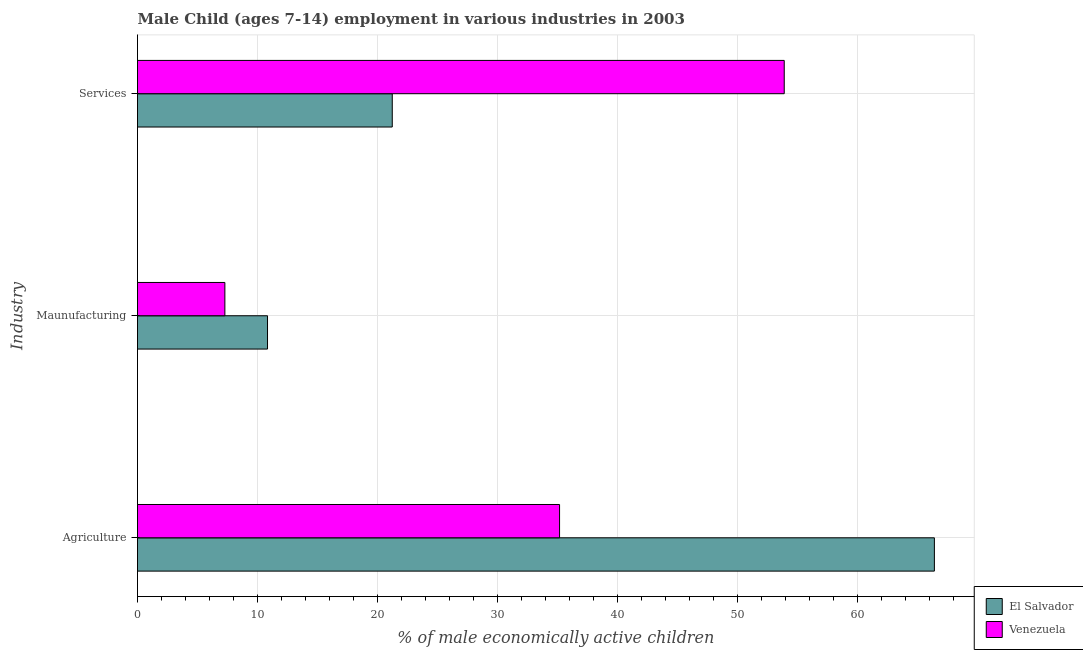How many groups of bars are there?
Offer a very short reply. 3. Are the number of bars on each tick of the Y-axis equal?
Offer a terse response. Yes. How many bars are there on the 2nd tick from the bottom?
Your answer should be compact. 2. What is the label of the 3rd group of bars from the top?
Provide a succinct answer. Agriculture. What is the percentage of economically active children in services in El Salvador?
Offer a very short reply. 21.22. Across all countries, what is the maximum percentage of economically active children in services?
Keep it short and to the point. 53.87. Across all countries, what is the minimum percentage of economically active children in manufacturing?
Keep it short and to the point. 7.28. In which country was the percentage of economically active children in agriculture maximum?
Make the answer very short. El Salvador. In which country was the percentage of economically active children in agriculture minimum?
Keep it short and to the point. Venezuela. What is the total percentage of economically active children in agriculture in the graph?
Your response must be concise. 101.54. What is the difference between the percentage of economically active children in agriculture in El Salvador and that in Venezuela?
Keep it short and to the point. 31.23. What is the difference between the percentage of economically active children in services in El Salvador and the percentage of economically active children in agriculture in Venezuela?
Provide a short and direct response. -13.94. What is the average percentage of economically active children in manufacturing per country?
Your answer should be very brief. 9.05. What is the difference between the percentage of economically active children in services and percentage of economically active children in manufacturing in Venezuela?
Your answer should be compact. 46.6. What is the ratio of the percentage of economically active children in agriculture in Venezuela to that in El Salvador?
Make the answer very short. 0.53. What is the difference between the highest and the second highest percentage of economically active children in manufacturing?
Offer a terse response. 3.55. What is the difference between the highest and the lowest percentage of economically active children in manufacturing?
Your response must be concise. 3.55. In how many countries, is the percentage of economically active children in agriculture greater than the average percentage of economically active children in agriculture taken over all countries?
Your answer should be very brief. 1. Is the sum of the percentage of economically active children in manufacturing in El Salvador and Venezuela greater than the maximum percentage of economically active children in agriculture across all countries?
Offer a terse response. No. What does the 2nd bar from the top in Services represents?
Give a very brief answer. El Salvador. What does the 2nd bar from the bottom in Services represents?
Offer a very short reply. Venezuela. Is it the case that in every country, the sum of the percentage of economically active children in agriculture and percentage of economically active children in manufacturing is greater than the percentage of economically active children in services?
Your response must be concise. No. How many bars are there?
Offer a terse response. 6. What is the difference between two consecutive major ticks on the X-axis?
Give a very brief answer. 10. Does the graph contain any zero values?
Keep it short and to the point. No. Does the graph contain grids?
Ensure brevity in your answer.  Yes. How many legend labels are there?
Ensure brevity in your answer.  2. How are the legend labels stacked?
Make the answer very short. Vertical. What is the title of the graph?
Your response must be concise. Male Child (ages 7-14) employment in various industries in 2003. Does "Spain" appear as one of the legend labels in the graph?
Offer a very short reply. No. What is the label or title of the X-axis?
Offer a very short reply. % of male economically active children. What is the label or title of the Y-axis?
Offer a terse response. Industry. What is the % of male economically active children in El Salvador in Agriculture?
Make the answer very short. 66.38. What is the % of male economically active children of Venezuela in Agriculture?
Keep it short and to the point. 35.16. What is the % of male economically active children in El Salvador in Maunufacturing?
Keep it short and to the point. 10.83. What is the % of male economically active children of Venezuela in Maunufacturing?
Your response must be concise. 7.28. What is the % of male economically active children in El Salvador in Services?
Provide a short and direct response. 21.22. What is the % of male economically active children in Venezuela in Services?
Your response must be concise. 53.87. Across all Industry, what is the maximum % of male economically active children in El Salvador?
Provide a succinct answer. 66.38. Across all Industry, what is the maximum % of male economically active children in Venezuela?
Offer a terse response. 53.87. Across all Industry, what is the minimum % of male economically active children of El Salvador?
Provide a succinct answer. 10.83. Across all Industry, what is the minimum % of male economically active children in Venezuela?
Keep it short and to the point. 7.28. What is the total % of male economically active children in El Salvador in the graph?
Give a very brief answer. 98.44. What is the total % of male economically active children in Venezuela in the graph?
Give a very brief answer. 96.31. What is the difference between the % of male economically active children of El Salvador in Agriculture and that in Maunufacturing?
Provide a short and direct response. 55.55. What is the difference between the % of male economically active children in Venezuela in Agriculture and that in Maunufacturing?
Ensure brevity in your answer.  27.88. What is the difference between the % of male economically active children in El Salvador in Agriculture and that in Services?
Provide a succinct answer. 45.16. What is the difference between the % of male economically active children of Venezuela in Agriculture and that in Services?
Keep it short and to the point. -18.72. What is the difference between the % of male economically active children in El Salvador in Maunufacturing and that in Services?
Your response must be concise. -10.39. What is the difference between the % of male economically active children in Venezuela in Maunufacturing and that in Services?
Your response must be concise. -46.6. What is the difference between the % of male economically active children in El Salvador in Agriculture and the % of male economically active children in Venezuela in Maunufacturing?
Make the answer very short. 59.11. What is the difference between the % of male economically active children of El Salvador in Agriculture and the % of male economically active children of Venezuela in Services?
Keep it short and to the point. 12.51. What is the difference between the % of male economically active children of El Salvador in Maunufacturing and the % of male economically active children of Venezuela in Services?
Make the answer very short. -43.05. What is the average % of male economically active children of El Salvador per Industry?
Give a very brief answer. 32.81. What is the average % of male economically active children of Venezuela per Industry?
Ensure brevity in your answer.  32.1. What is the difference between the % of male economically active children in El Salvador and % of male economically active children in Venezuela in Agriculture?
Your answer should be compact. 31.23. What is the difference between the % of male economically active children of El Salvador and % of male economically active children of Venezuela in Maunufacturing?
Give a very brief answer. 3.55. What is the difference between the % of male economically active children of El Salvador and % of male economically active children of Venezuela in Services?
Your answer should be very brief. -32.65. What is the ratio of the % of male economically active children of El Salvador in Agriculture to that in Maunufacturing?
Offer a terse response. 6.13. What is the ratio of the % of male economically active children in Venezuela in Agriculture to that in Maunufacturing?
Your answer should be very brief. 4.83. What is the ratio of the % of male economically active children in El Salvador in Agriculture to that in Services?
Your answer should be very brief. 3.13. What is the ratio of the % of male economically active children in Venezuela in Agriculture to that in Services?
Your answer should be compact. 0.65. What is the ratio of the % of male economically active children in El Salvador in Maunufacturing to that in Services?
Keep it short and to the point. 0.51. What is the ratio of the % of male economically active children in Venezuela in Maunufacturing to that in Services?
Offer a very short reply. 0.14. What is the difference between the highest and the second highest % of male economically active children in El Salvador?
Offer a very short reply. 45.16. What is the difference between the highest and the second highest % of male economically active children of Venezuela?
Provide a succinct answer. 18.72. What is the difference between the highest and the lowest % of male economically active children in El Salvador?
Offer a very short reply. 55.55. What is the difference between the highest and the lowest % of male economically active children of Venezuela?
Make the answer very short. 46.6. 